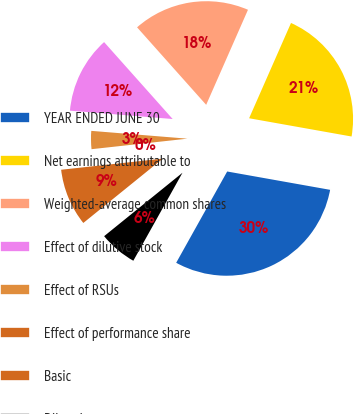<chart> <loc_0><loc_0><loc_500><loc_500><pie_chart><fcel>YEAR ENDED JUNE 30<fcel>Net earnings attributable to<fcel>Weighted-average common shares<fcel>Effect of dilutive stock<fcel>Effect of RSUs<fcel>Effect of performance share<fcel>Basic<fcel>Diluted<nl><fcel>30.3%<fcel>21.21%<fcel>18.18%<fcel>12.12%<fcel>3.03%<fcel>0.0%<fcel>9.09%<fcel>6.06%<nl></chart> 